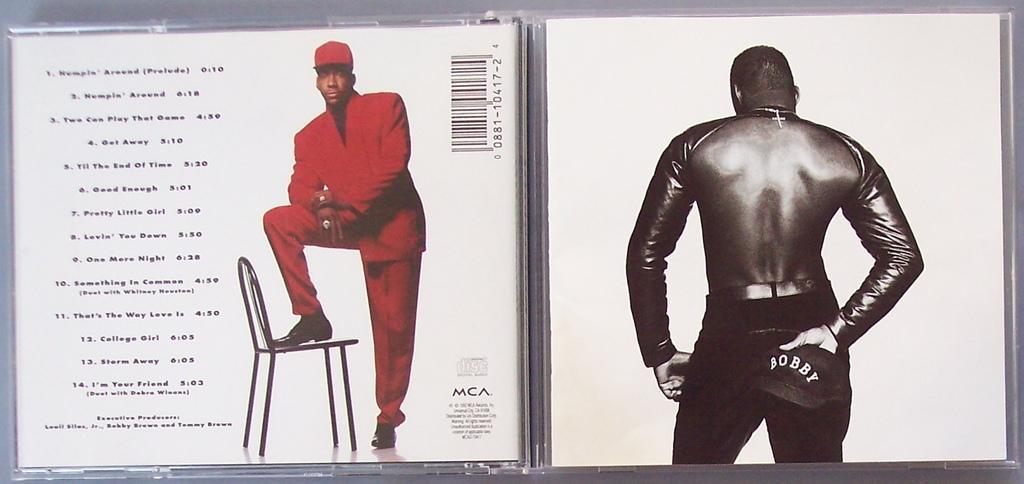Describe this image in one or two sentences. In this image on the left side I can see a person and a chair, some texts are written on the left side and on the right side we can see a person, holding cap. 